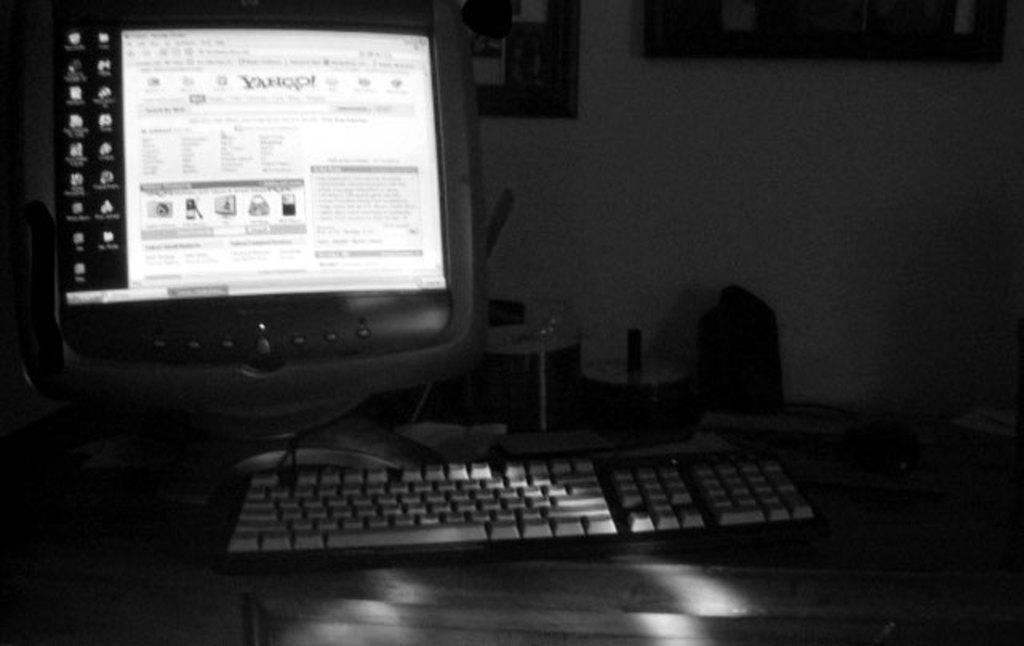Name of the website?
Offer a very short reply. Yahoo. 